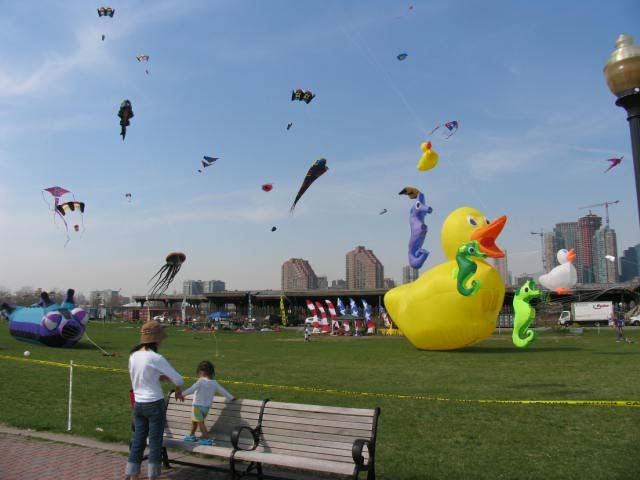Describe the objects in this image and their specific colors. I can see bench in darkgray, gray, and black tones, people in darkgray, black, lavender, and gray tones, people in darkgray, gray, and black tones, kite in darkgray and gray tones, and truck in darkgray, black, gray, and lightgray tones in this image. 